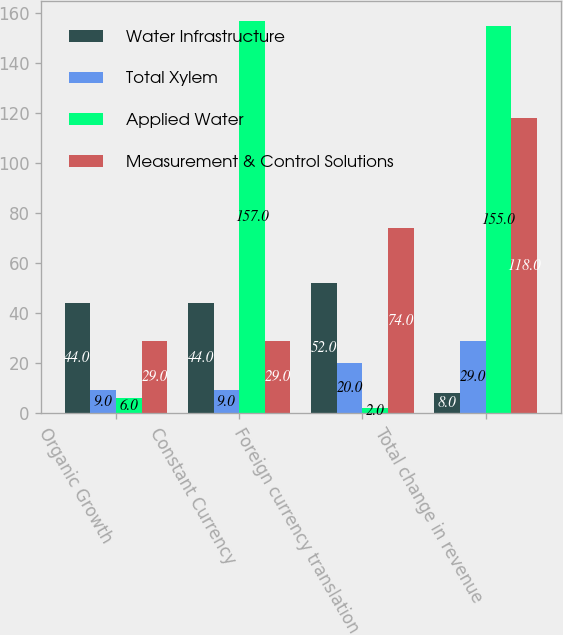<chart> <loc_0><loc_0><loc_500><loc_500><stacked_bar_chart><ecel><fcel>Organic Growth<fcel>Constant Currency<fcel>Foreign currency translation<fcel>Total change in revenue<nl><fcel>Water Infrastructure<fcel>44<fcel>44<fcel>52<fcel>8<nl><fcel>Total Xylem<fcel>9<fcel>9<fcel>20<fcel>29<nl><fcel>Applied Water<fcel>6<fcel>157<fcel>2<fcel>155<nl><fcel>Measurement & Control Solutions<fcel>29<fcel>29<fcel>74<fcel>118<nl></chart> 